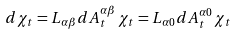Convert formula to latex. <formula><loc_0><loc_0><loc_500><loc_500>d \chi _ { t } = L _ { \alpha \beta } d A _ { t } ^ { \alpha \beta } \, \chi _ { t } = L _ { \alpha 0 } d A _ { t } ^ { \alpha 0 } \, \chi _ { t }</formula> 